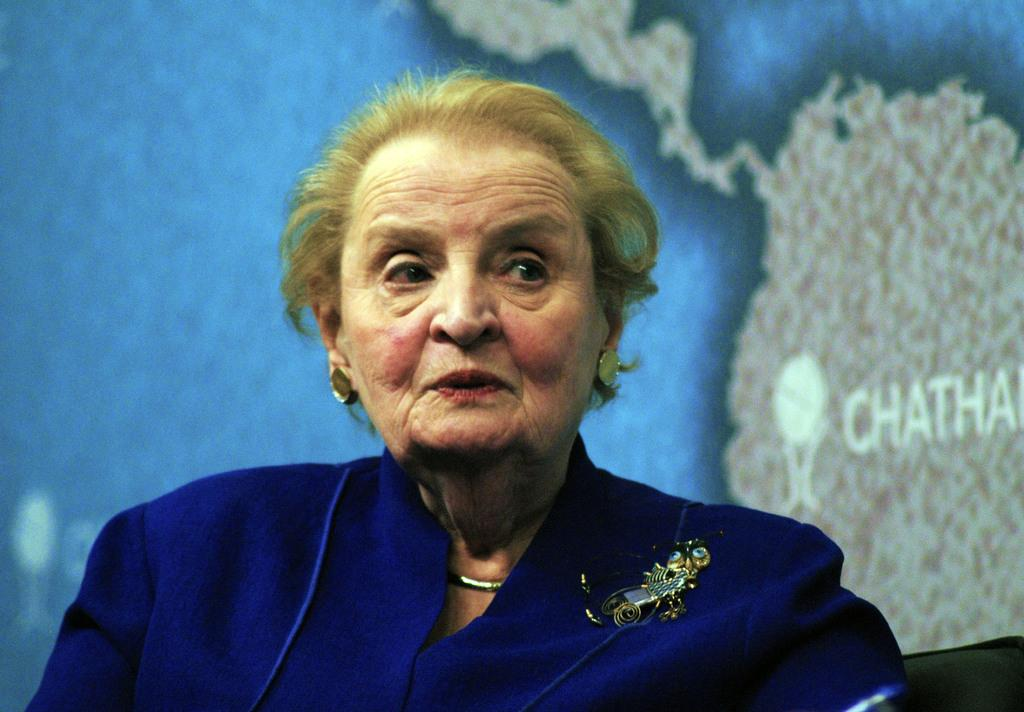Who is present in the image? There is a woman in the image. What can be seen on the wall in the image? There is a poster of a map on the wall in the image. What type of ornament is hanging from the ceiling in the image? There is no ornament hanging from the ceiling in the image. What kind of sail can be seen in the image? There is no sail present in the image. 